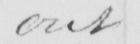Can you tell me what this handwritten text says? out 